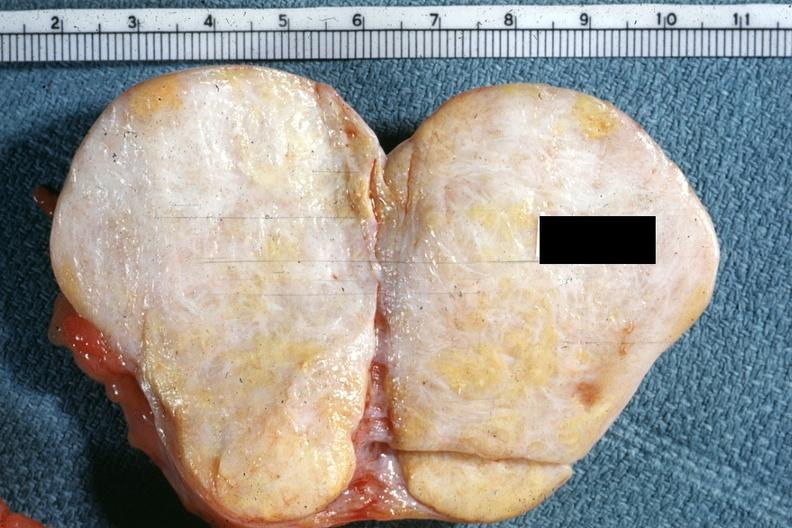s female reproductive present?
Answer the question using a single word or phrase. Yes 